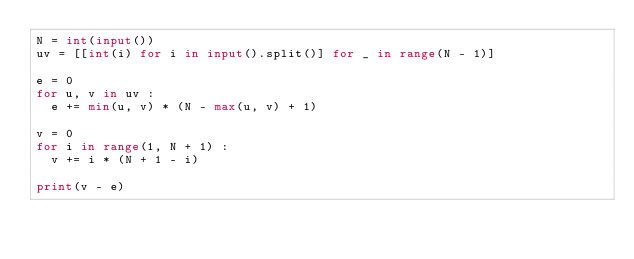<code> <loc_0><loc_0><loc_500><loc_500><_Python_>N = int(input())
uv = [[int(i) for i in input().split()] for _ in range(N - 1)]

e = 0
for u, v in uv :
  e += min(u, v) * (N - max(u, v) + 1)

v = 0
for i in range(1, N + 1) :
  v += i * (N + 1 - i)
  
print(v - e)</code> 